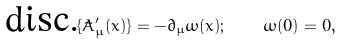Convert formula to latex. <formula><loc_0><loc_0><loc_500><loc_500>\text {disc.} \{ \tilde { A } _ { \mu } ^ { \prime } ( x ) \} = - \partial _ { \mu } \omega ( x ) ; \quad \omega ( 0 ) = 0 ,</formula> 